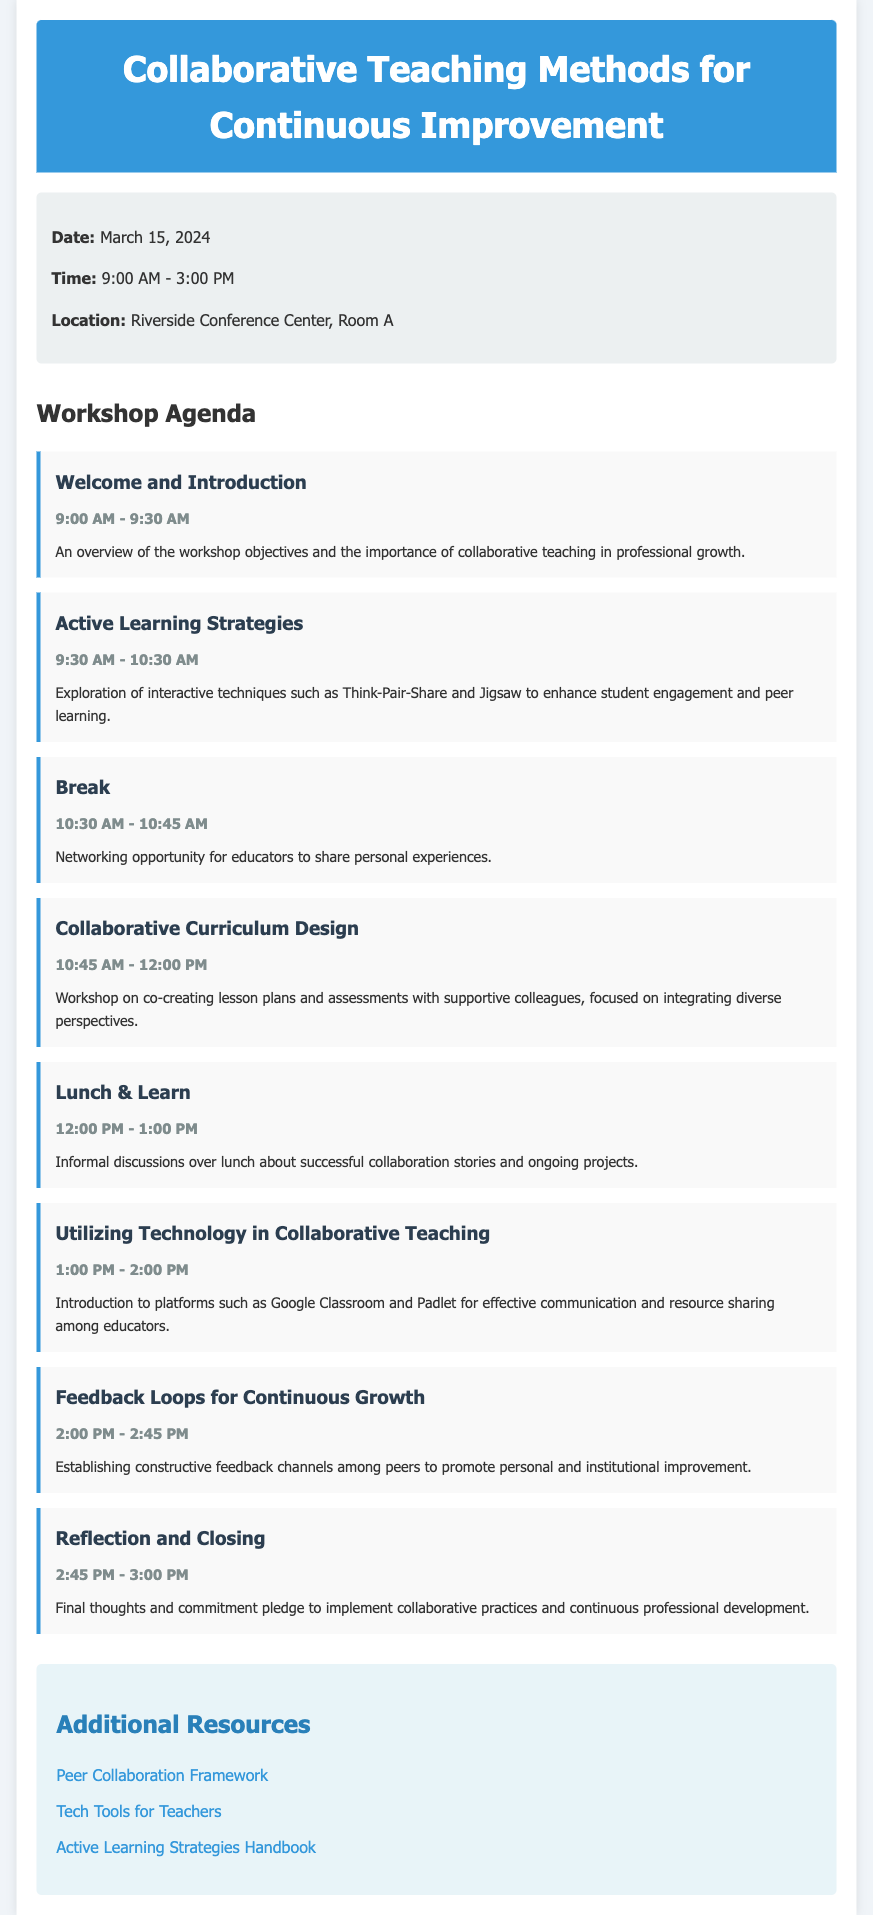What is the date of the workshop? The date of the workshop is specified in the workshop information section.
Answer: March 15, 2024 What time does the workshop start? The start time is provided in the workshop information, indicating when the activities begin.
Answer: 9:00 AM How long is the session on Active Learning Strategies? The duration can be calculated based on the stated start and end times of this session in the agenda.
Answer: 1 hour What is the main purpose of the Welcome and Introduction session? The description of the session outlines its goals related to collaborative teaching and professional growth.
Answer: Overview of the workshop objectives Which session involves Lunch & Learn? This is identified as part of the agenda where informal discussions take place during lunchtime.
Answer: Lunch & Learn What technology platforms are introduced in the workshop? The session details specify which platforms will be discussed for communication and resource sharing.
Answer: Google Classroom and Padlet What is a key feature of the Feedback Loops for Continuous Growth session? The focus of this session is highlighted in the description regarding promoting improvement.
Answer: Constructive feedback channels What is included in the Additional Resources section? The resources provided are listed as links to further educational tools and frameworks related to teaching.
Answer: Peer Collaboration Framework What is the final activity of the workshop? The last item in the agenda specifies what will occur at the close of the workshop.
Answer: Reflection and Closing 